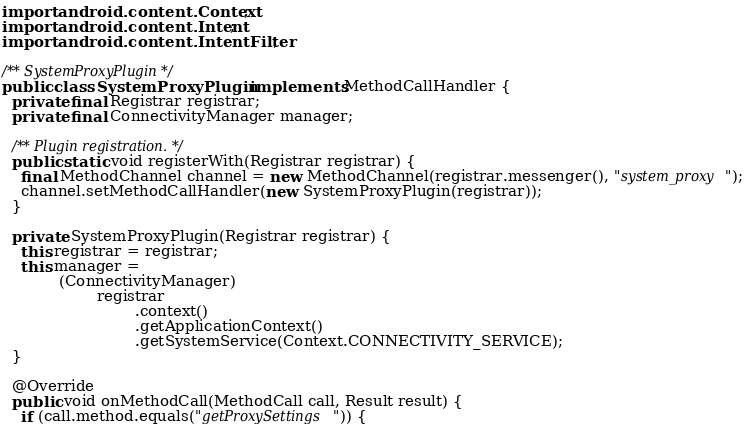Convert code to text. <code><loc_0><loc_0><loc_500><loc_500><_Java_>import android.content.Context;
import android.content.Intent;
import android.content.IntentFilter;

/** SystemProxyPlugin */
public class SystemProxyPlugin implements MethodCallHandler {
  private final Registrar registrar;
  private final ConnectivityManager manager;

  /** Plugin registration. */
  public static void registerWith(Registrar registrar) {
    final MethodChannel channel = new MethodChannel(registrar.messenger(), "system_proxy");
    channel.setMethodCallHandler(new SystemProxyPlugin(registrar));
  }

  private SystemProxyPlugin(Registrar registrar) {
    this.registrar = registrar;
    this.manager =
            (ConnectivityManager)
                    registrar
                            .context()
                            .getApplicationContext()
                            .getSystemService(Context.CONNECTIVITY_SERVICE);
  }

  @Override
  public void onMethodCall(MethodCall call, Result result) {
    if (call.method.equals("getProxySettings")) {</code> 